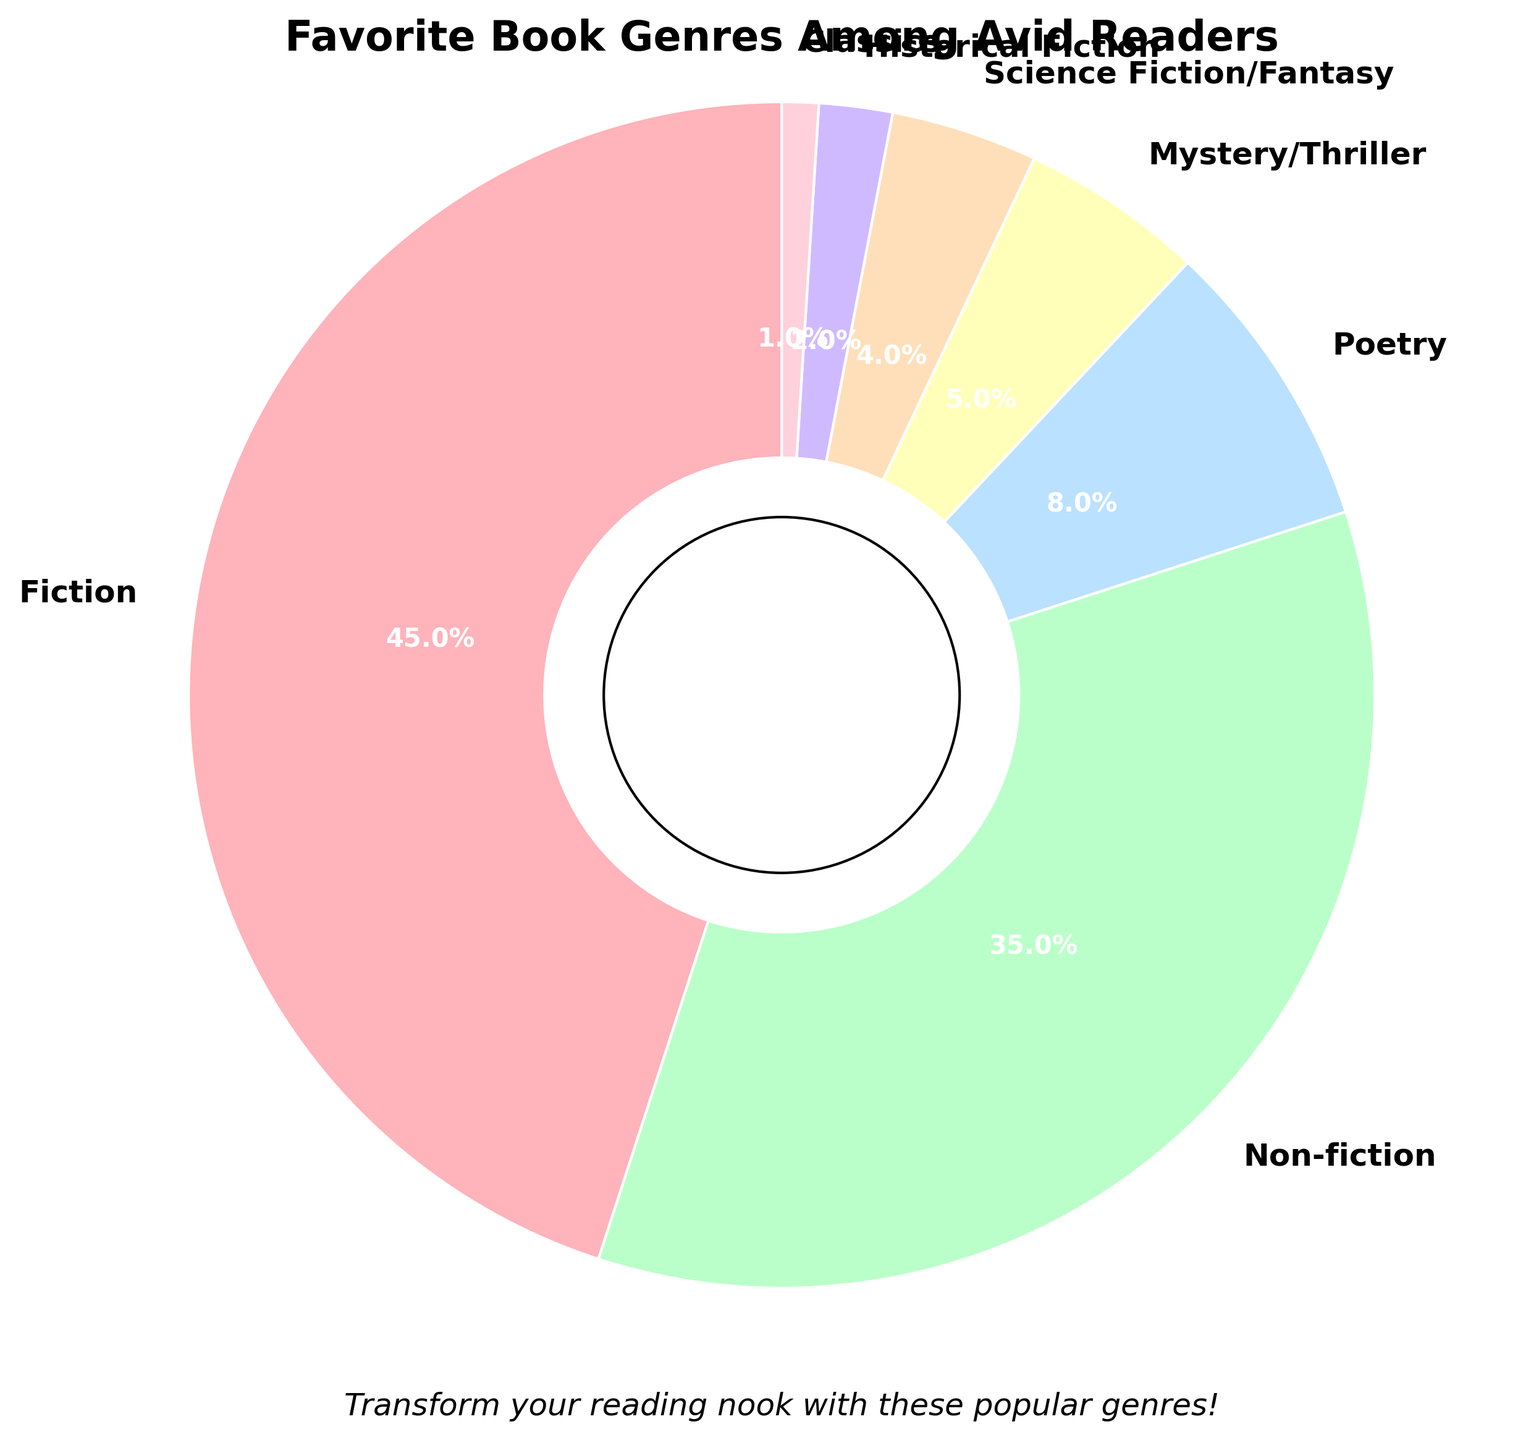Which genre is the most popular among avid readers? The genre with the highest percentage on the pie chart is the most popular. Referring to the chart, Fiction has the highest percentage.
Answer: Fiction How much higher is the percentage of Fiction compared to Poetry? Identify the percentages for Fiction and Poetry from the pie chart. Fiction is 45% and Poetry is 8%. The difference is 45% - 8% = 37%.
Answer: 37% What is the combined percentage of Mystery/Thriller and Science Fiction/Fantasy? Look at the percentages for both genres: Mystery/Thriller is 5% and Science Fiction/Fantasy is 4%. Adding them together, 5% + 4% = 9%.
Answer: 9% Which genres together make up more than 50% of the total? Identify the genres and their percentages: Fiction (45%), Non-fiction (35%), Poetry (8%), Mystery/Thriller (5%), Science Fiction/Fantasy (4%), Historical Fiction (2%), Classics (1%). Adding Fiction (45%) and Non-fiction (35%) equals 80%, which is more than 50%.
Answer: Fiction and Non-Fiction Are there any genres with less than 5% representation? Look at the percentages: Mystery/Thriller (5%), Science Fiction/Fantasy (4%), Historical Fiction (2%), and Classics (1%) are all less than 5%.
Answer: Mystery/Thriller, Science Fiction/Fantasy, Historical Fiction, and Classics What genre has the smallest representation among avid readers? Identify the genre with the smallest percentage. On the pie chart, Classics has the smallest representation with 1%.
Answer: Classics Compare the combined percentages of Poetry and Historical Fiction. Which one is closer to Non-fiction? Poetry is 8% and Historical Fiction is 2%, their combined percentage is 8% + 2% = 10%. Non-fiction is 35%, closer to Poetry.
Answer: Poetry Is there any genre that is double or more the percentage of Poetry? Poetry is 8%. Fiction (45%) and Non-Fiction (35%) are both more than double of Poetry’s percentage.
Answer: Fiction and Non-Fiction How does the percentage of Science Fiction/Fantasy compare to Historical Fiction? Compare their percentages: Science Fiction/Fantasy is 4% and Historical Fiction is 2%, meaning Science Fiction/Fantasy is double Historical Fiction.
Answer: Science Fiction/Fantasy is double Historical Fiction 